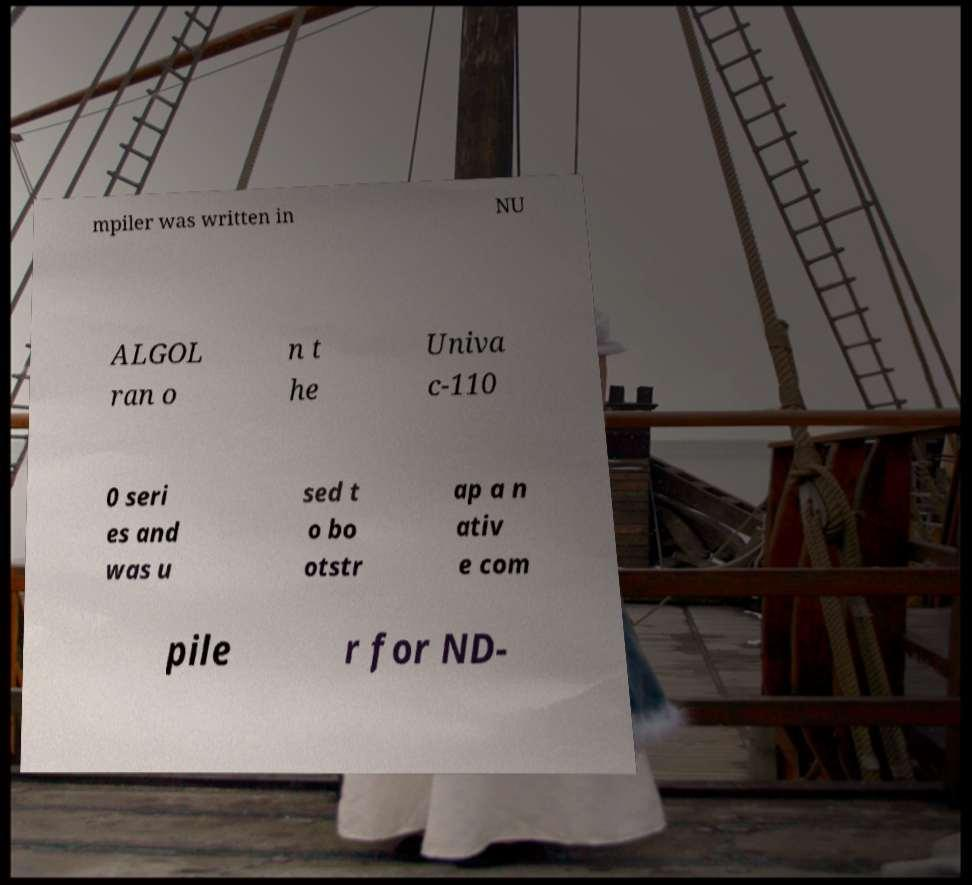Can you read and provide the text displayed in the image?This photo seems to have some interesting text. Can you extract and type it out for me? mpiler was written in NU ALGOL ran o n t he Univa c-110 0 seri es and was u sed t o bo otstr ap a n ativ e com pile r for ND- 